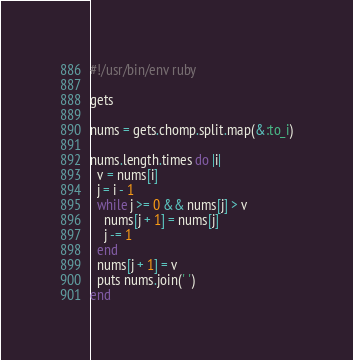Convert code to text. <code><loc_0><loc_0><loc_500><loc_500><_Ruby_>#!/usr/bin/env ruby

gets

nums = gets.chomp.split.map(&:to_i)

nums.length.times do |i|
  v = nums[i]
  j = i - 1
  while j >= 0 && nums[j] > v
    nums[j + 1] = nums[j]
    j -= 1
  end
  nums[j + 1] = v
  puts nums.join(' ')
end</code> 